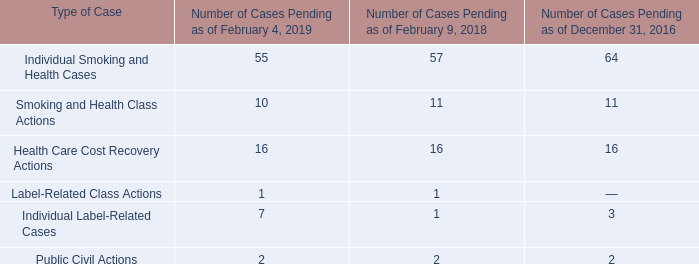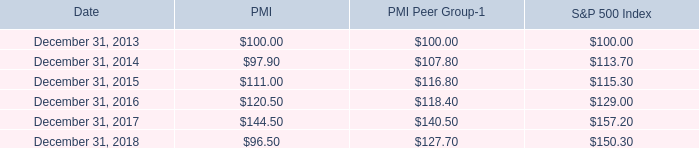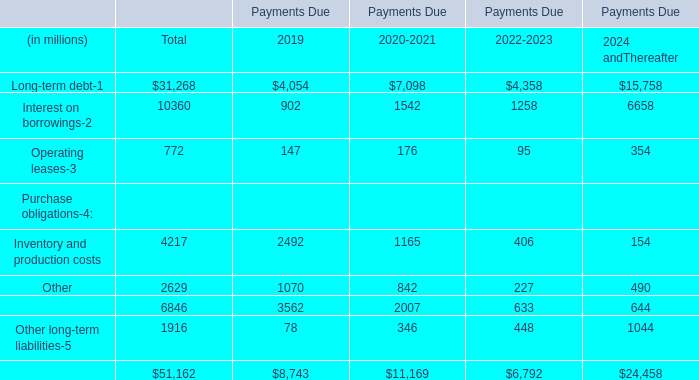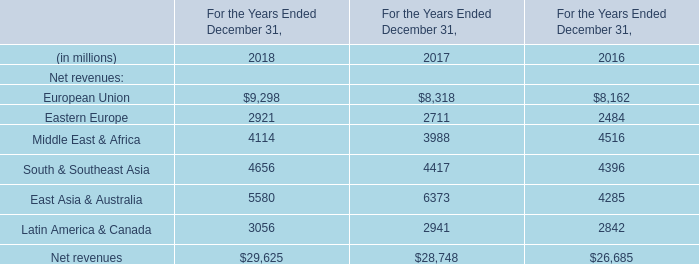What is the Payments Due 2019 for Operating leases? (in million) 
Answer: 147. 